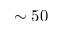<formula> <loc_0><loc_0><loc_500><loc_500>\sim 5 0</formula> 